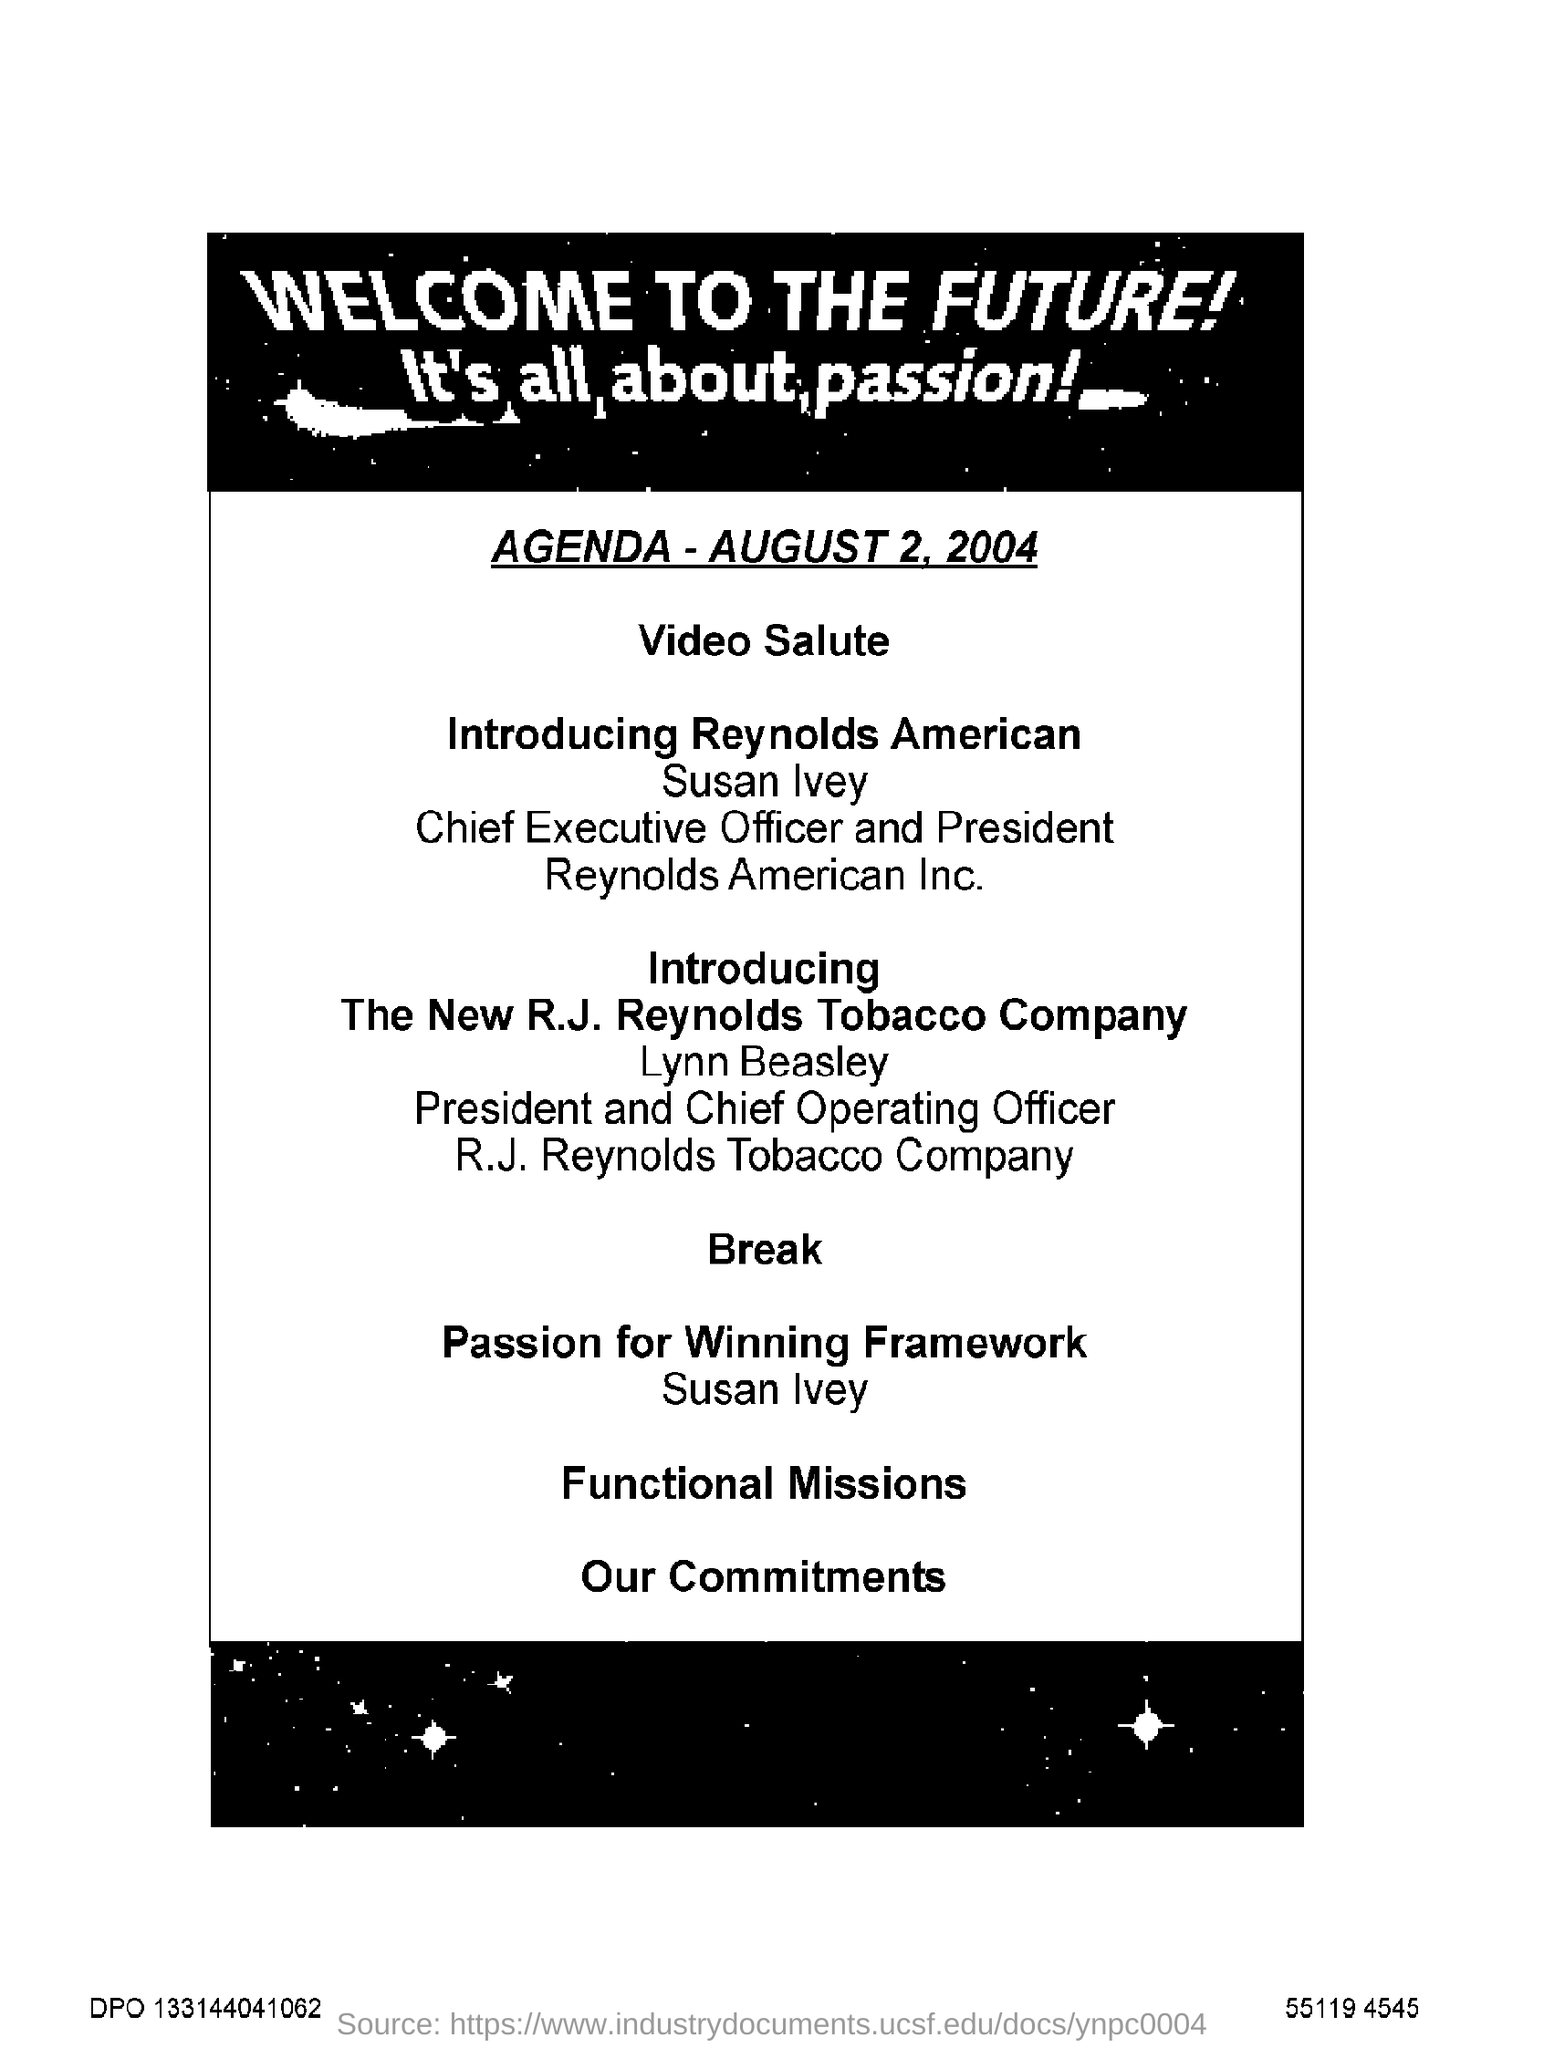What is given in bold capital letter on top go page?
Offer a very short reply. Welcome to the future. What is the AGENDA date given?
Your response must be concise. AUGUST 2, 2004. 